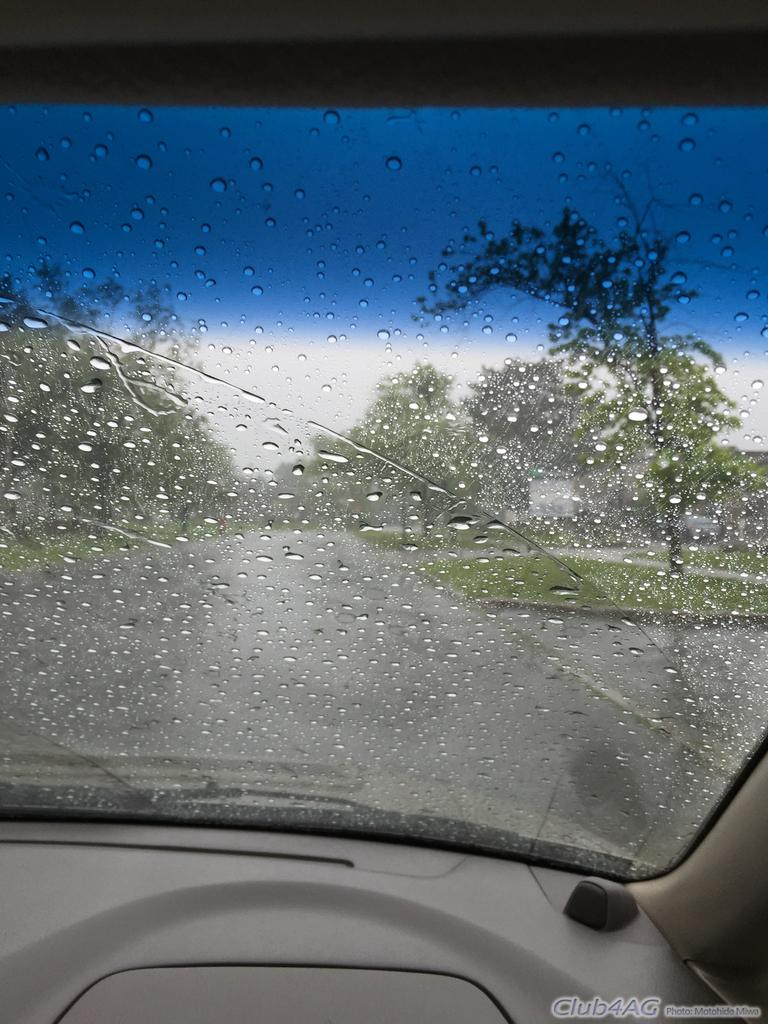What is the main subject of the image? The main subject of the image is a vehicle glass window. What can be seen on the glass window? Water bubbles are visible on the glass window. What is visible beyond the glass window? A road, trees, grass, and the sky are visible through the glass window. What type of leather material can be seen in the image? There is no leather material present in the image; it features a vehicle glass window with water bubbles and a view of the surrounding environment. 